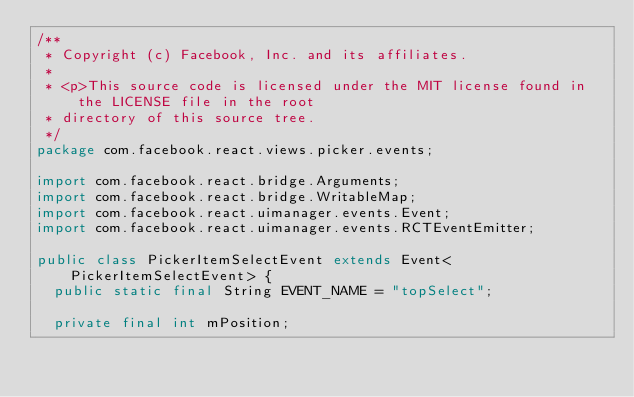Convert code to text. <code><loc_0><loc_0><loc_500><loc_500><_Java_>/**
 * Copyright (c) Facebook, Inc. and its affiliates.
 *
 * <p>This source code is licensed under the MIT license found in the LICENSE file in the root
 * directory of this source tree.
 */
package com.facebook.react.views.picker.events;

import com.facebook.react.bridge.Arguments;
import com.facebook.react.bridge.WritableMap;
import com.facebook.react.uimanager.events.Event;
import com.facebook.react.uimanager.events.RCTEventEmitter;

public class PickerItemSelectEvent extends Event<PickerItemSelectEvent> {
  public static final String EVENT_NAME = "topSelect";

  private final int mPosition;
</code> 